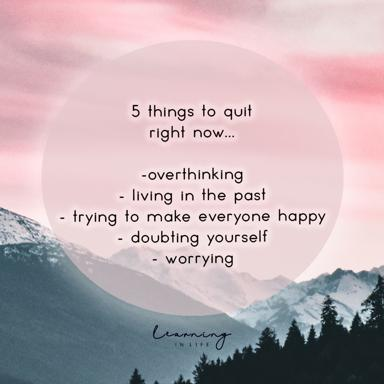What is the significance of the background image in relation to the text? The tranquil scene of mountains and lush trees encapsulated within a pink circle in the background of the image adds a layer of meaning to the phrases listed. This peaceful landscape serves as a visual metaphor suggesting that one can achieve peace and emotional freedom by ceasing these five harmful behaviors. It beckons the viewer to seek inner calm akin to the peacefulness of the nature scene, thereby aligning the visual and textual elements to promote a holistic approach to mental health. 